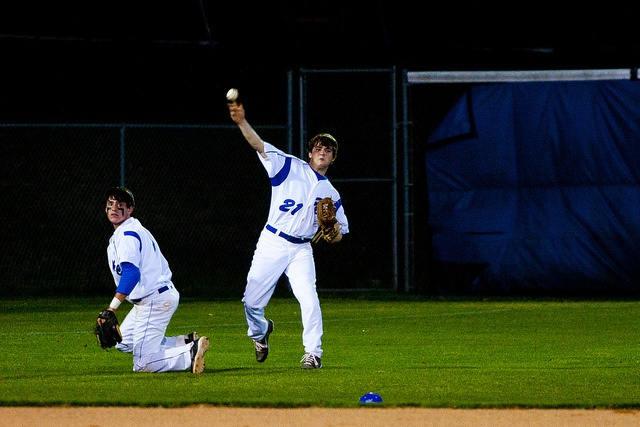Describe the objects in this image and their specific colors. I can see people in black and lavender tones, people in black and lavender tones, baseball glove in black, olive, maroon, and gray tones, baseball glove in black, olive, and gray tones, and sports ball in black, ivory, darkgray, lightgray, and tan tones in this image. 